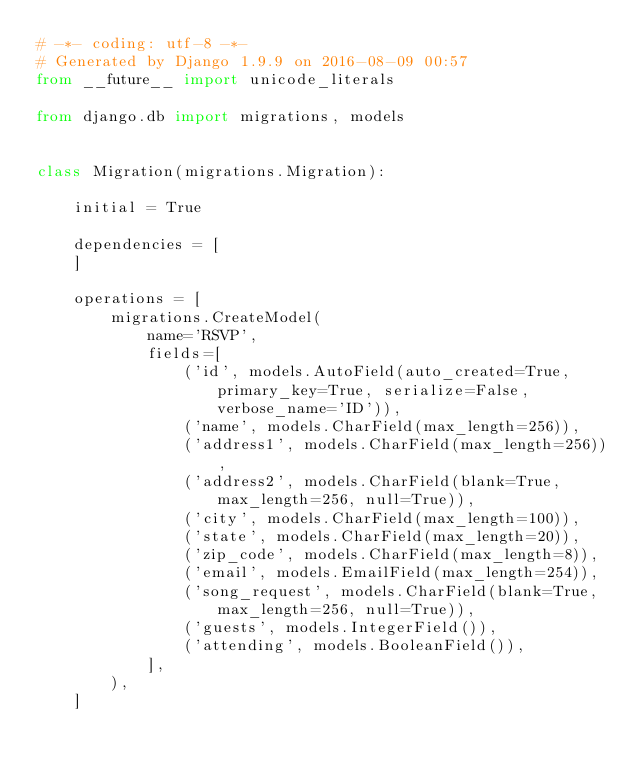<code> <loc_0><loc_0><loc_500><loc_500><_Python_># -*- coding: utf-8 -*-
# Generated by Django 1.9.9 on 2016-08-09 00:57
from __future__ import unicode_literals

from django.db import migrations, models


class Migration(migrations.Migration):

    initial = True

    dependencies = [
    ]

    operations = [
        migrations.CreateModel(
            name='RSVP',
            fields=[
                ('id', models.AutoField(auto_created=True, primary_key=True, serialize=False, verbose_name='ID')),
                ('name', models.CharField(max_length=256)),
                ('address1', models.CharField(max_length=256)),
                ('address2', models.CharField(blank=True, max_length=256, null=True)),
                ('city', models.CharField(max_length=100)),
                ('state', models.CharField(max_length=20)),
                ('zip_code', models.CharField(max_length=8)),
                ('email', models.EmailField(max_length=254)),
                ('song_request', models.CharField(blank=True, max_length=256, null=True)),
                ('guests', models.IntegerField()),
                ('attending', models.BooleanField()),
            ],
        ),
    ]
</code> 